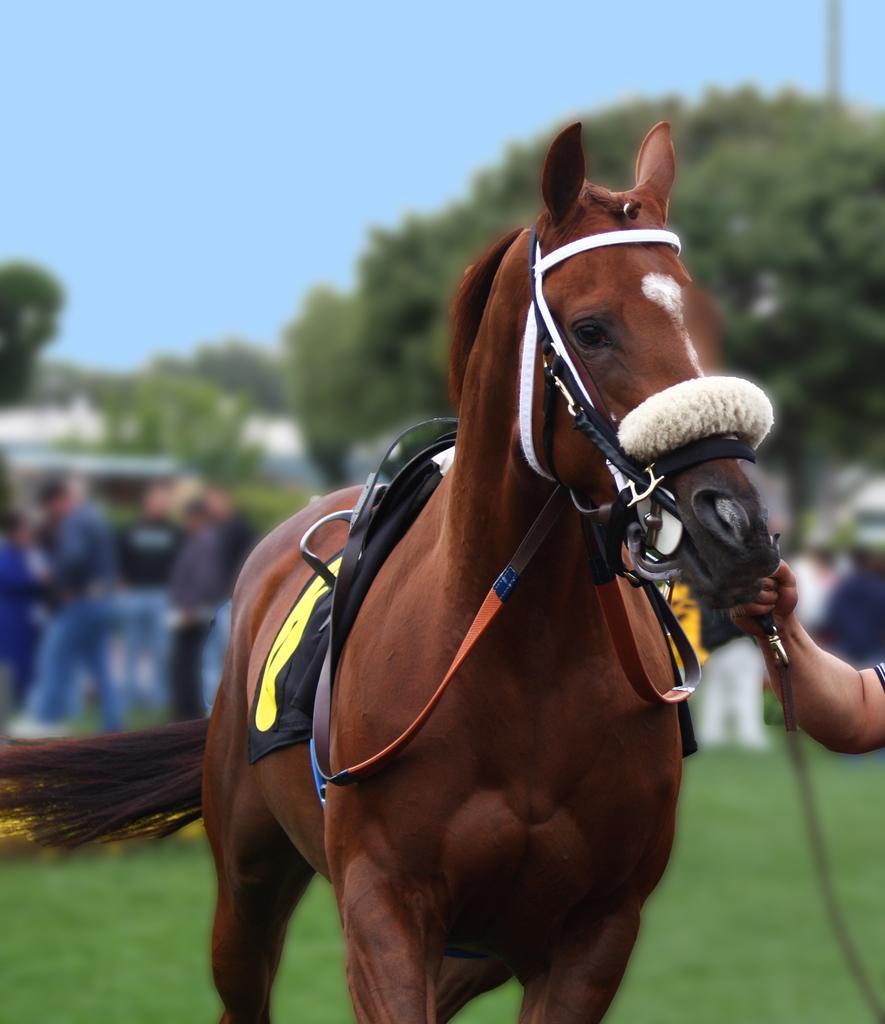Describe this image in one or two sentences. At the top we can see clear blue sky. These are trees. We can see persons standing here. In Front of the picture we can see a horse. At the right side of the picture we can see partial hand of a man holding a horse belt with his hands. This is a grass. 